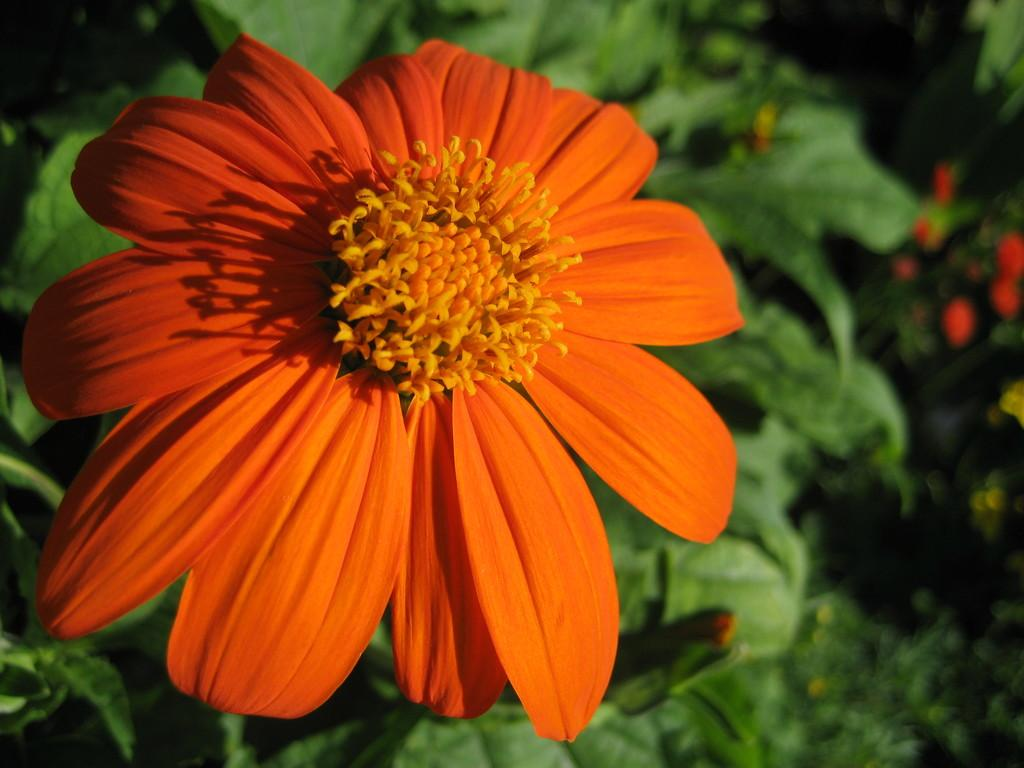What is the main subject of the image? There is a flower in the image. What color is the flower? The flower is orange in color. What else can be seen in the image besides the flower? There are green leaves in the image. Where are the leaves located in relation to the flower? The leaves are located at the back side of the image. What type of spade is being used to dig around the flower in the image? There is no spade or digging activity present in the image; it features a flower and green leaves. 